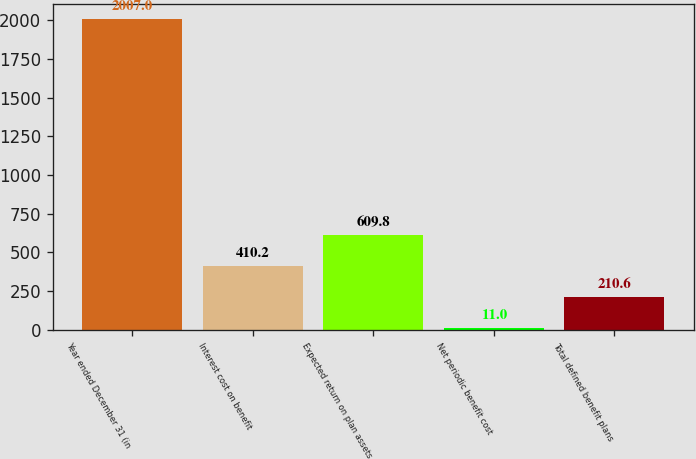Convert chart to OTSL. <chart><loc_0><loc_0><loc_500><loc_500><bar_chart><fcel>Year ended December 31 (in<fcel>Interest cost on benefit<fcel>Expected return on plan assets<fcel>Net periodic benefit cost<fcel>Total defined benefit plans<nl><fcel>2007<fcel>410.2<fcel>609.8<fcel>11<fcel>210.6<nl></chart> 